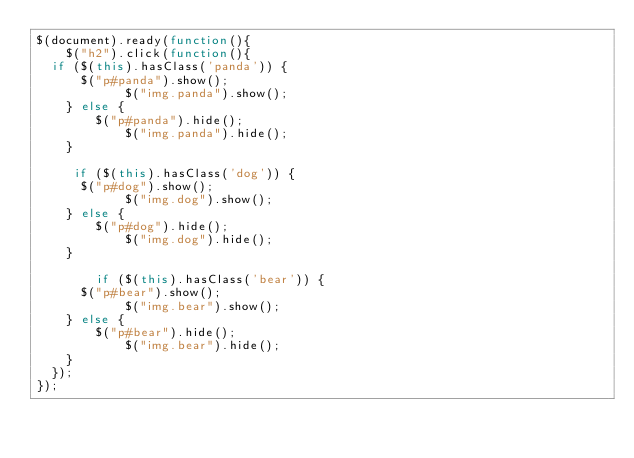<code> <loc_0><loc_0><loc_500><loc_500><_JavaScript_>$(document).ready(function(){
	$("h2").click(function(){
  if ($(this).hasClass('panda')) {
      $("p#panda").show();
			$("img.panda").show();
    } else {
    	$("p#panda").hide();
			$("img.panda").hide();
    }

     if ($(this).hasClass('dog')) {
      $("p#dog").show();
			$("img.dog").show();
    } else {
    	$("p#dog").hide();
			$("img.dog").hide();
    }

        if ($(this).hasClass('bear')) {
      $("p#bear").show();
			$("img.bear").show();
    } else {
    	$("p#bear").hide();
			$("img.bear").hide();
    }
  });
});
</code> 